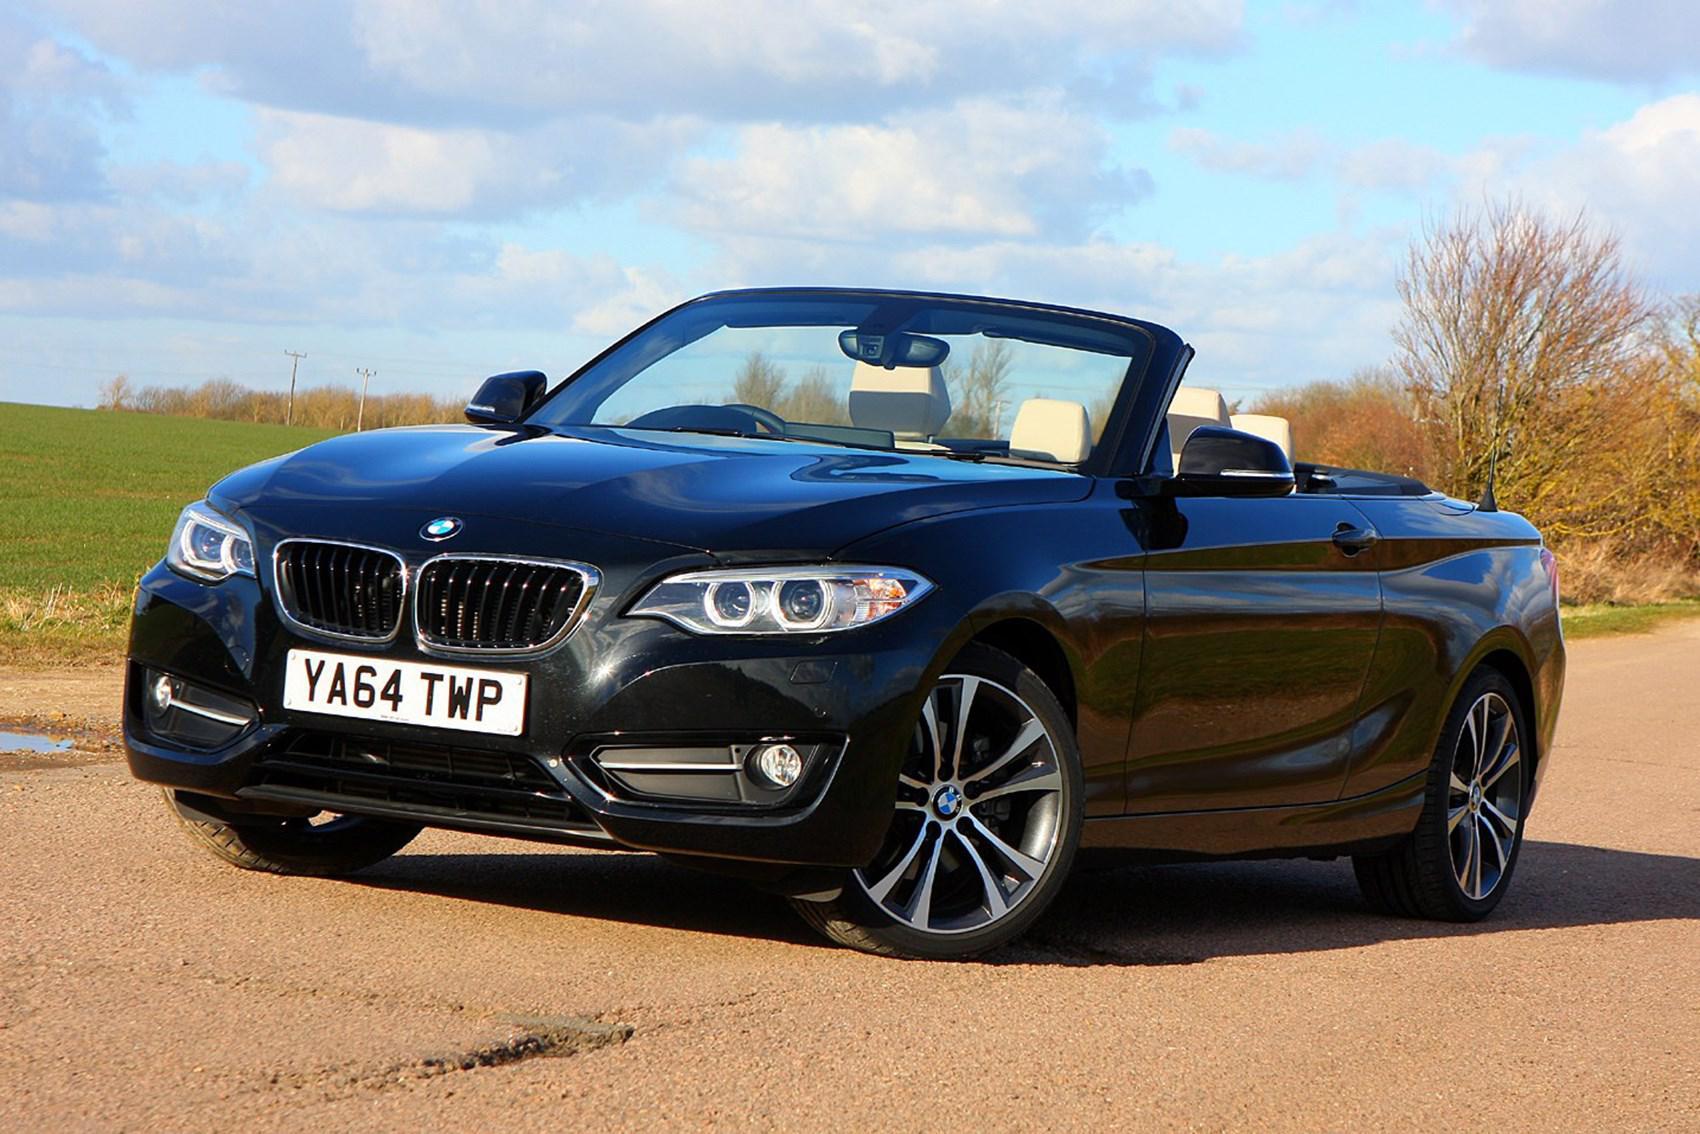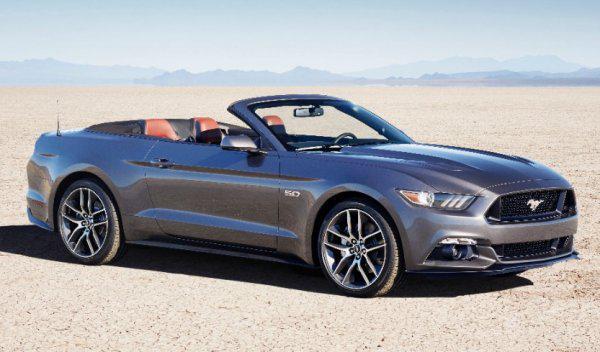The first image is the image on the left, the second image is the image on the right. Given the left and right images, does the statement "One of the convertibles is red." hold true? Answer yes or no. No. The first image is the image on the left, the second image is the image on the right. Analyze the images presented: Is the assertion "a convertible is parked on a sandy lot with grass in the background" valid? Answer yes or no. Yes. 